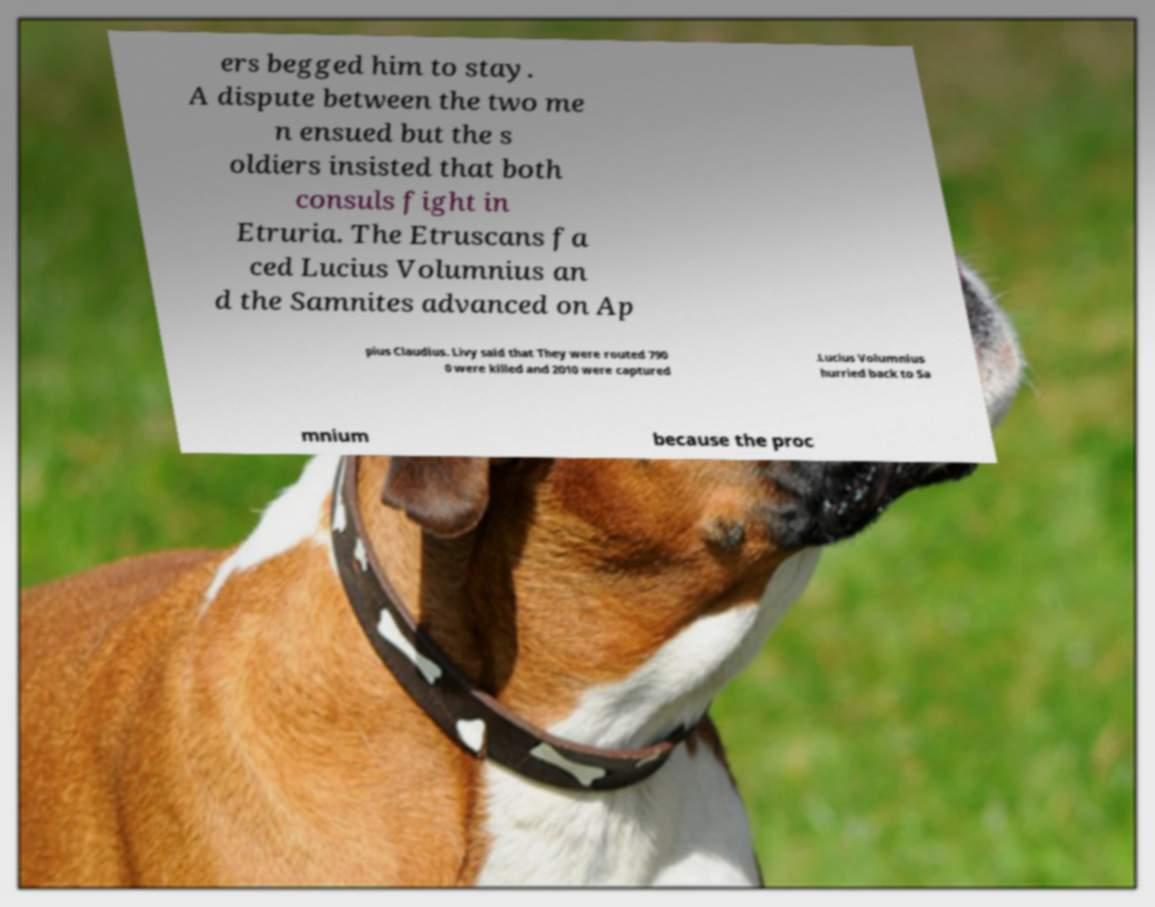Could you extract and type out the text from this image? ers begged him to stay. A dispute between the two me n ensued but the s oldiers insisted that both consuls fight in Etruria. The Etruscans fa ced Lucius Volumnius an d the Samnites advanced on Ap pius Claudius. Livy said that They were routed 790 0 were killed and 2010 were captured .Lucius Volumnius hurried back to Sa mnium because the proc 